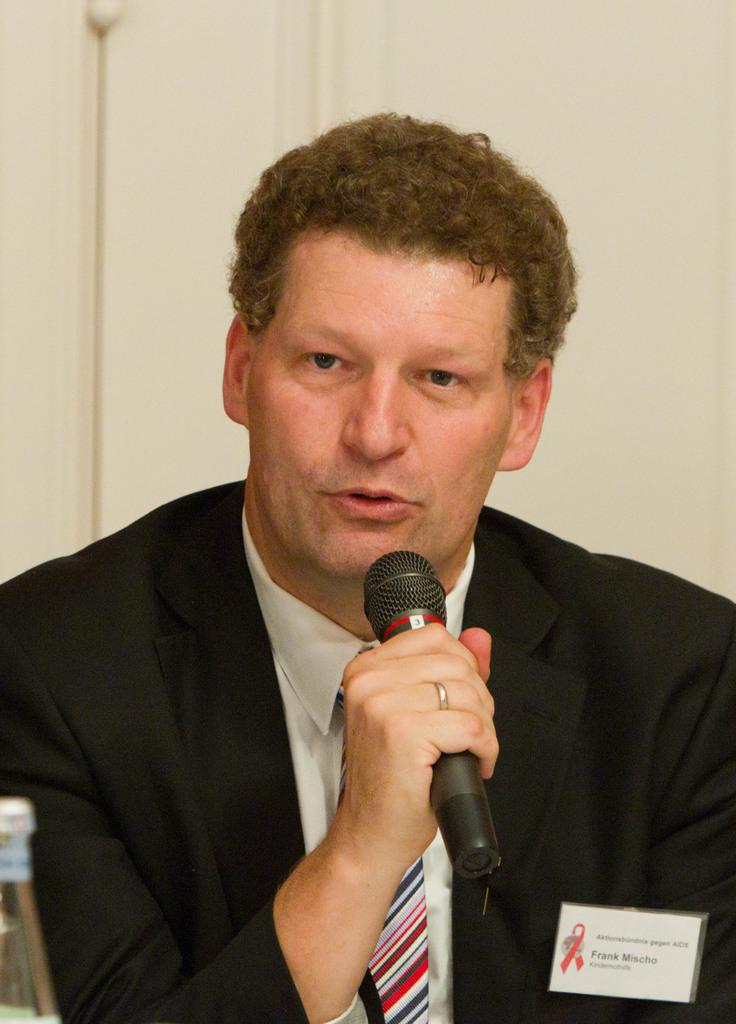What is the person in the image doing? The person is holding a mic and speaking. What might the person be using the mic for? The person might be using the mic for public speaking, singing, or presenting. What can be seen on the left side of the image? There is a bottle in the front on the left side of the image. What is the background of the image like? There is a white wall in the background of the image. What type of hat is the person wearing in the image? There is no hat visible in the image; the person is only holding a mic and speaking. 